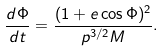Convert formula to latex. <formula><loc_0><loc_0><loc_500><loc_500>\frac { d \Phi } { d t } = \frac { ( 1 + e \cos \Phi ) ^ { 2 } } { p ^ { 3 / 2 } M } .</formula> 